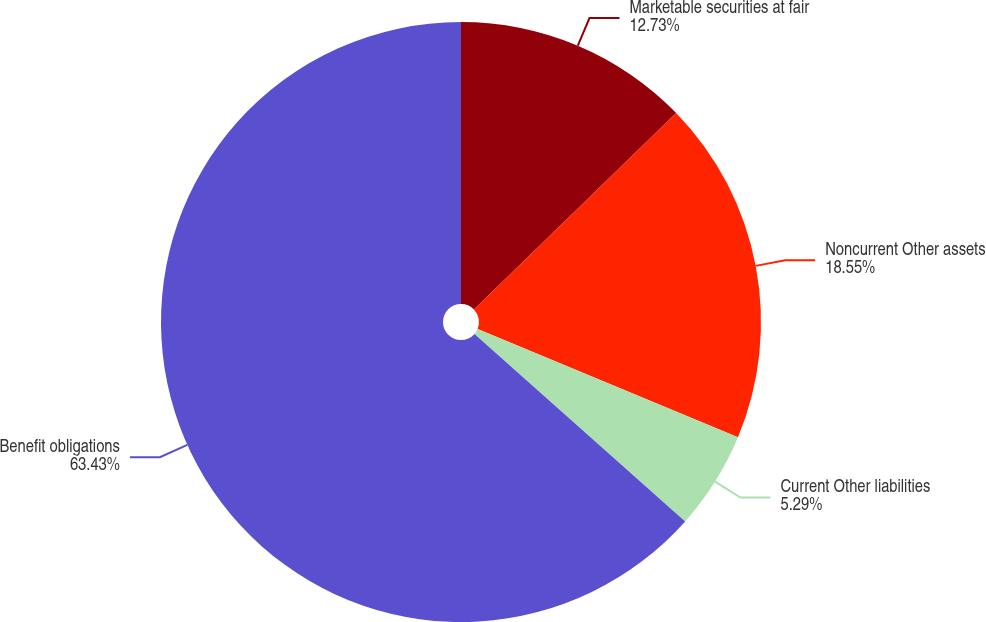Convert chart to OTSL. <chart><loc_0><loc_0><loc_500><loc_500><pie_chart><fcel>Marketable securities at fair<fcel>Noncurrent Other assets<fcel>Current Other liabilities<fcel>Benefit obligations<nl><fcel>12.73%<fcel>18.55%<fcel>5.29%<fcel>63.43%<nl></chart> 